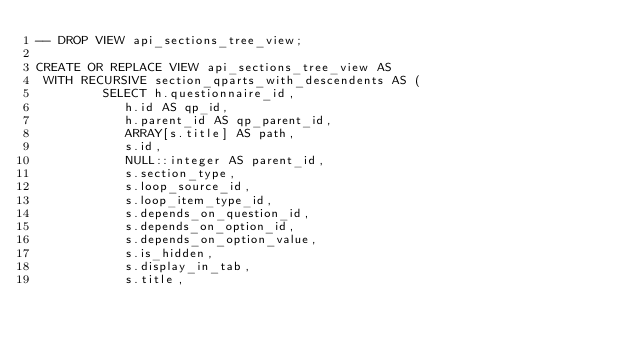<code> <loc_0><loc_0><loc_500><loc_500><_SQL_>-- DROP VIEW api_sections_tree_view;

CREATE OR REPLACE VIEW api_sections_tree_view AS
 WITH RECURSIVE section_qparts_with_descendents AS (
         SELECT h.questionnaire_id,
            h.id AS qp_id,
            h.parent_id AS qp_parent_id,
            ARRAY[s.title] AS path,
            s.id,
            NULL::integer AS parent_id,
            s.section_type,
            s.loop_source_id,
            s.loop_item_type_id,
            s.depends_on_question_id,
            s.depends_on_option_id,
            s.depends_on_option_value,
            s.is_hidden,
            s.display_in_tab,
            s.title,</code> 